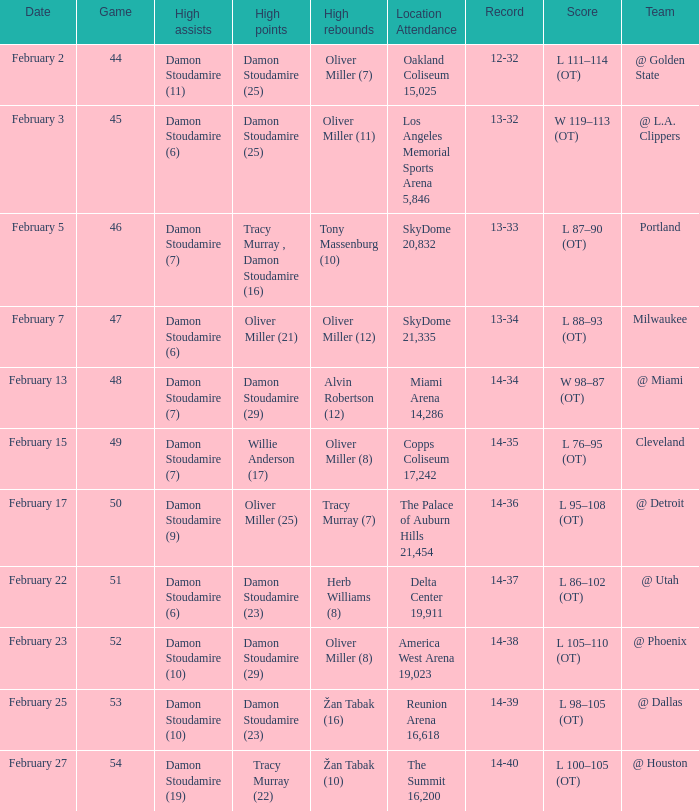How many locations have a record of 14-38? 1.0. 